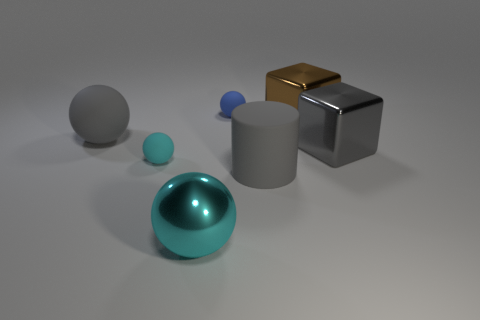Compare the sizes of the objects. Which is the largest and which is the smallest? Based on the image, the largest object is the gray cylinder in the middle, towering over the other items in terms of height. In contrast, the smallest object is the tiny blue sphere to the left of the cylinder, which is diminutive in size compared to all other elements in the scene. 